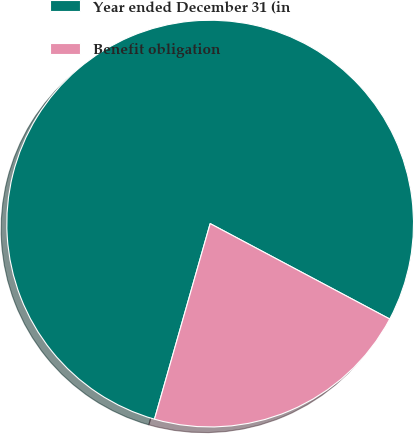Convert chart. <chart><loc_0><loc_0><loc_500><loc_500><pie_chart><fcel>Year ended December 31 (in<fcel>Benefit obligation<nl><fcel>78.36%<fcel>21.64%<nl></chart> 